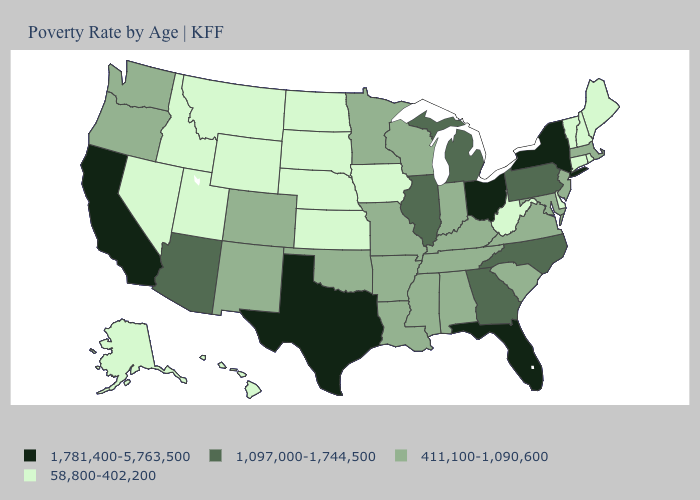What is the value of Wyoming?
Quick response, please. 58,800-402,200. Does California have the highest value in the West?
Be succinct. Yes. What is the highest value in the USA?
Keep it brief. 1,781,400-5,763,500. Is the legend a continuous bar?
Give a very brief answer. No. What is the value of Arkansas?
Quick response, please. 411,100-1,090,600. Which states hav the highest value in the West?
Keep it brief. California. Does California have a higher value than Washington?
Concise answer only. Yes. Among the states that border Iowa , does Nebraska have the lowest value?
Give a very brief answer. Yes. What is the value of South Dakota?
Quick response, please. 58,800-402,200. Name the states that have a value in the range 411,100-1,090,600?
Keep it brief. Alabama, Arkansas, Colorado, Indiana, Kentucky, Louisiana, Maryland, Massachusetts, Minnesota, Mississippi, Missouri, New Jersey, New Mexico, Oklahoma, Oregon, South Carolina, Tennessee, Virginia, Washington, Wisconsin. What is the value of Maine?
Short answer required. 58,800-402,200. Name the states that have a value in the range 1,097,000-1,744,500?
Keep it brief. Arizona, Georgia, Illinois, Michigan, North Carolina, Pennsylvania. Name the states that have a value in the range 58,800-402,200?
Write a very short answer. Alaska, Connecticut, Delaware, Hawaii, Idaho, Iowa, Kansas, Maine, Montana, Nebraska, Nevada, New Hampshire, North Dakota, Rhode Island, South Dakota, Utah, Vermont, West Virginia, Wyoming. Does New York have the highest value in the USA?
Concise answer only. Yes. What is the lowest value in the USA?
Quick response, please. 58,800-402,200. 